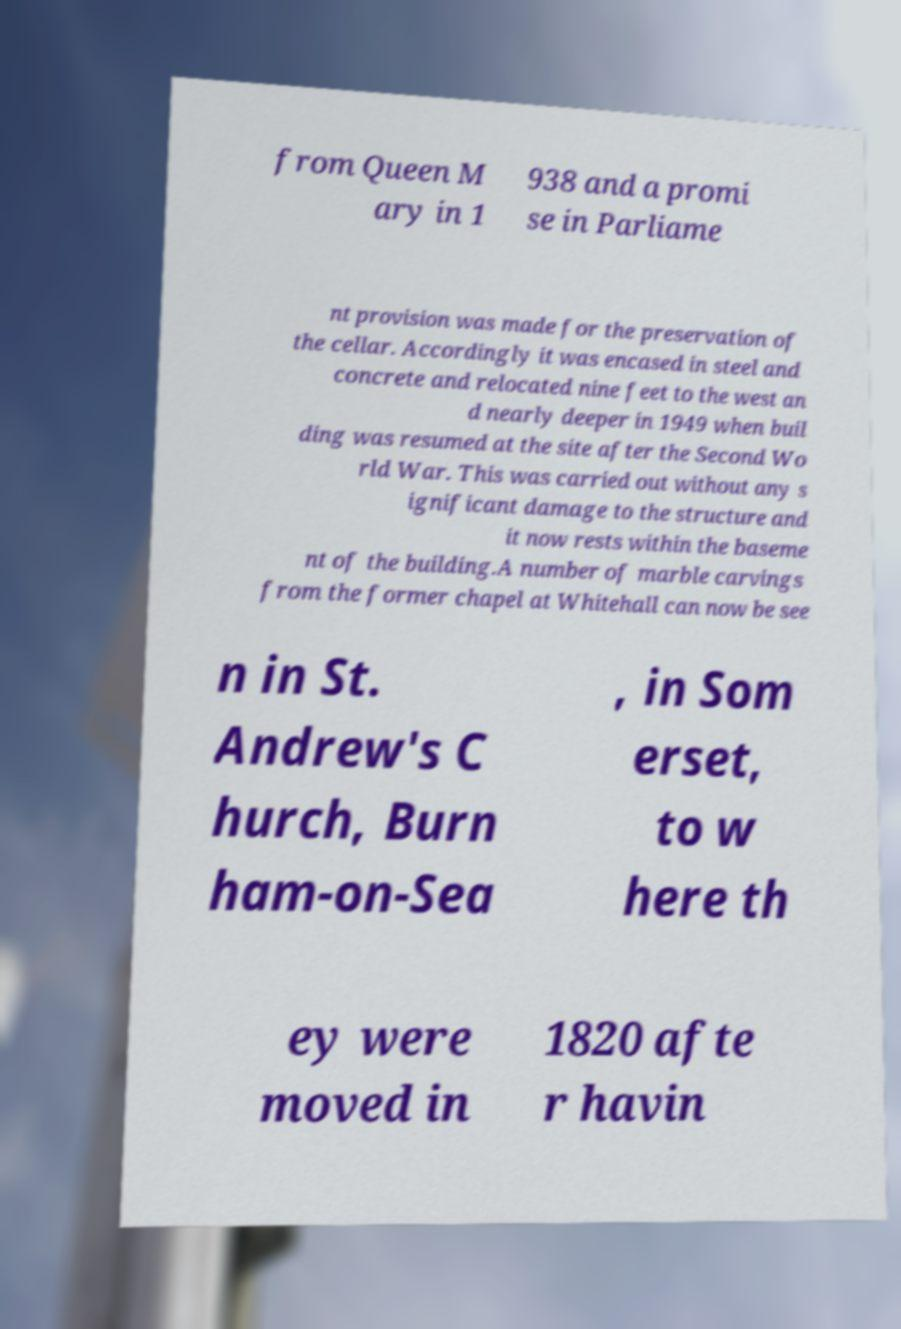Can you read and provide the text displayed in the image?This photo seems to have some interesting text. Can you extract and type it out for me? from Queen M ary in 1 938 and a promi se in Parliame nt provision was made for the preservation of the cellar. Accordingly it was encased in steel and concrete and relocated nine feet to the west an d nearly deeper in 1949 when buil ding was resumed at the site after the Second Wo rld War. This was carried out without any s ignificant damage to the structure and it now rests within the baseme nt of the building.A number of marble carvings from the former chapel at Whitehall can now be see n in St. Andrew's C hurch, Burn ham-on-Sea , in Som erset, to w here th ey were moved in 1820 afte r havin 